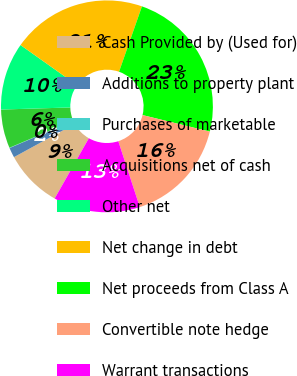<chart> <loc_0><loc_0><loc_500><loc_500><pie_chart><fcel>Cash Provided by (Used for)<fcel>Additions to property plant<fcel>Purchases of marketable<fcel>Acquisitions net of cash<fcel>Other net<fcel>Net change in debt<fcel>Net proceeds from Class A<fcel>Convertible note hedge<fcel>Warrant transactions<nl><fcel>8.83%<fcel>1.52%<fcel>0.05%<fcel>5.91%<fcel>10.3%<fcel>20.54%<fcel>23.47%<fcel>16.15%<fcel>13.23%<nl></chart> 